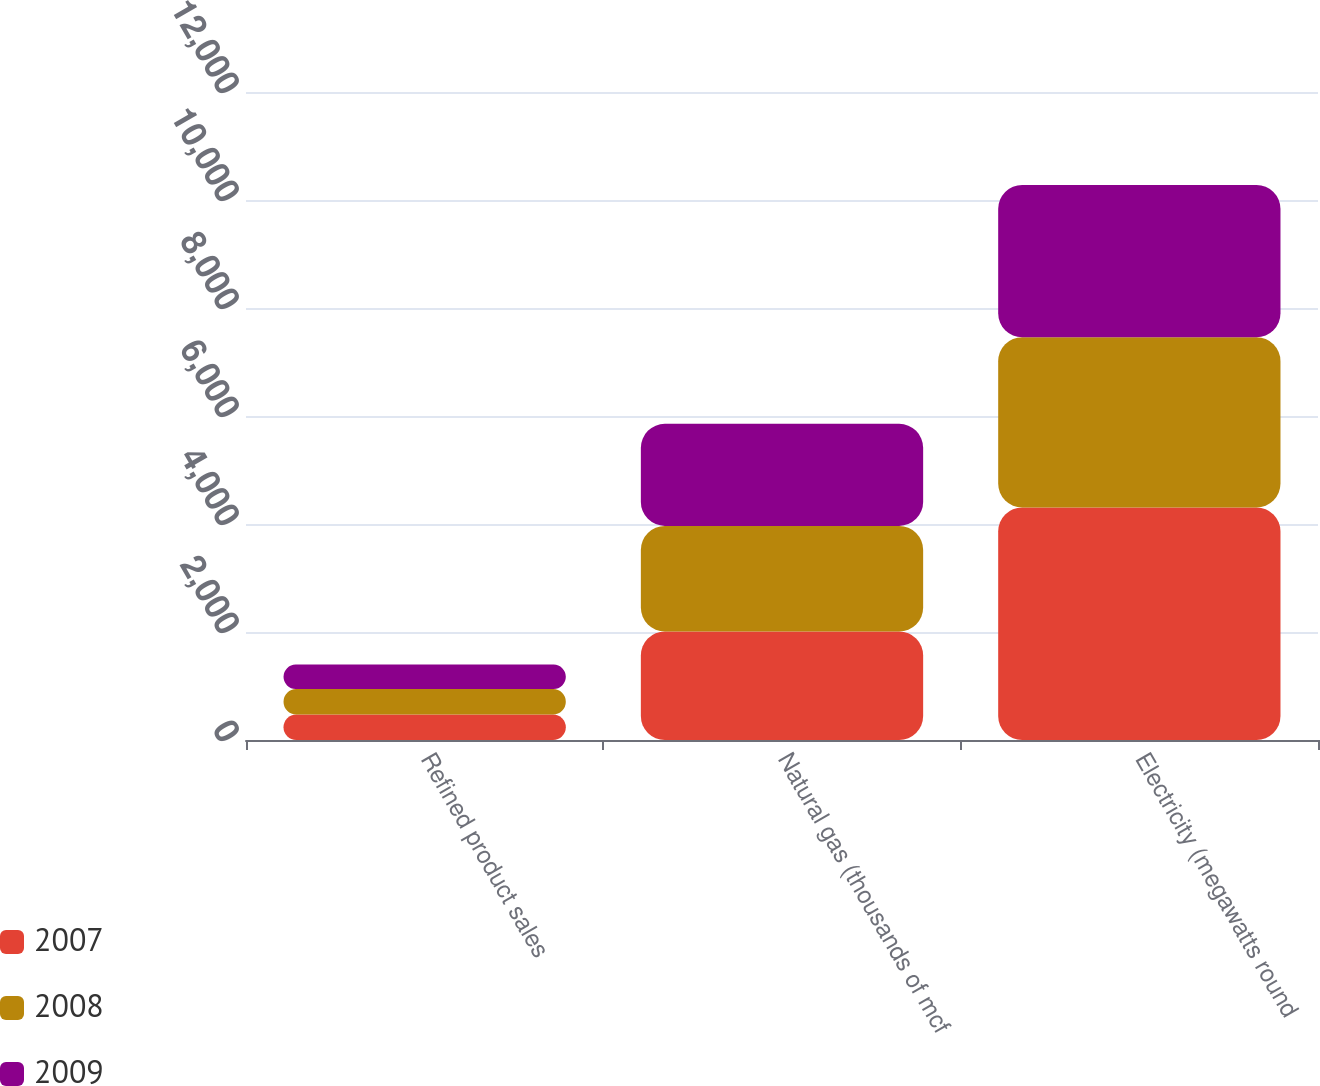Convert chart to OTSL. <chart><loc_0><loc_0><loc_500><loc_500><stacked_bar_chart><ecel><fcel>Refined product sales<fcel>Natural gas (thousands of mcf<fcel>Electricity (megawatts round<nl><fcel>2007<fcel>473<fcel>2010<fcel>4306<nl><fcel>2008<fcel>472<fcel>1955<fcel>3152<nl><fcel>2009<fcel>451<fcel>1890<fcel>2821<nl></chart> 